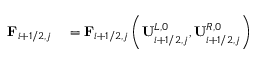Convert formula to latex. <formula><loc_0><loc_0><loc_500><loc_500>\begin{array} { r l } { F _ { i + 1 / 2 , j } } & = F _ { i + 1 / 2 , j } \left ( U _ { i + 1 / 2 , j } ^ { L , 0 } , U _ { i + 1 / 2 , j } ^ { R , 0 } \right ) } \end{array}</formula> 